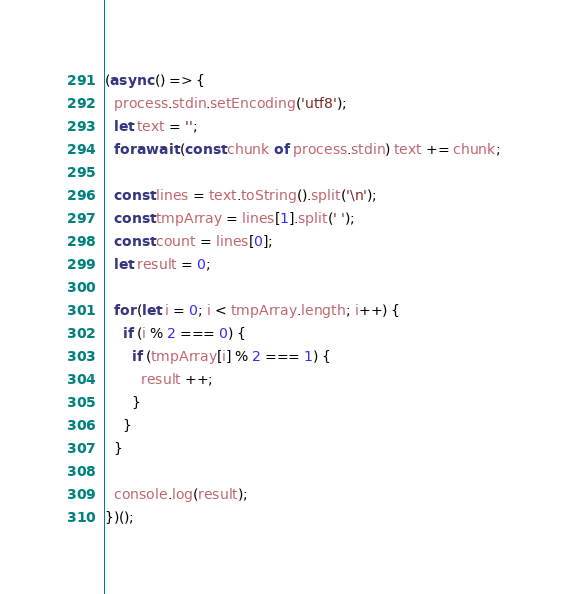Convert code to text. <code><loc_0><loc_0><loc_500><loc_500><_JavaScript_>(async () => {
  process.stdin.setEncoding('utf8');
  let text = '';
  for await (const chunk of process.stdin) text += chunk;

  const lines = text.toString().split('\n');
  const tmpArray = lines[1].split(' ');
  const count = lines[0];
  let result = 0;

  for (let i = 0; i < tmpArray.length; i++) {
    if (i % 2 === 0) {
      if (tmpArray[i] % 2 === 1) {
        result ++;
      }
    }
  }

  console.log(result);
})();

</code> 